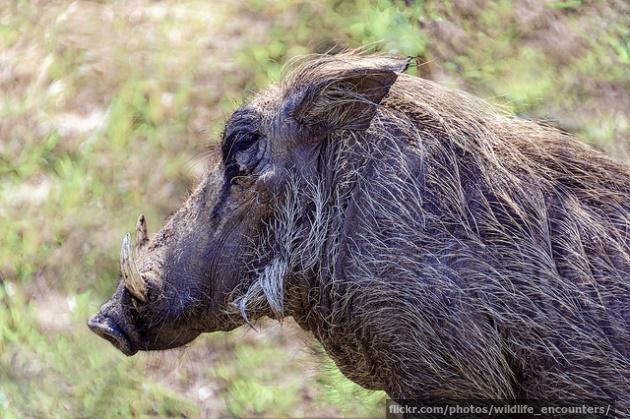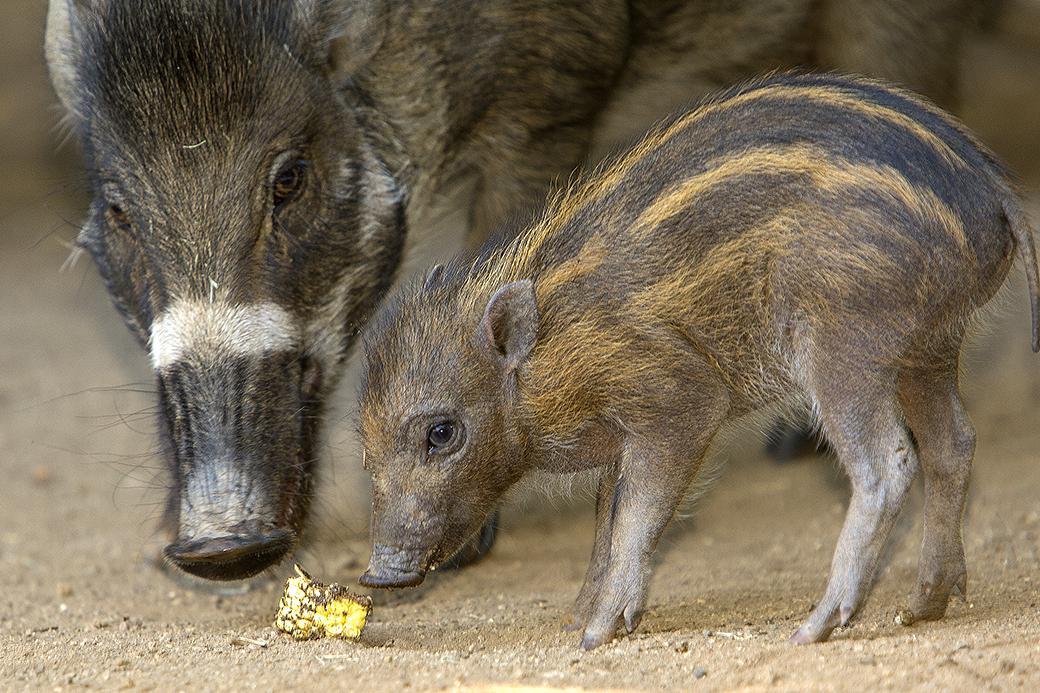The first image is the image on the left, the second image is the image on the right. Evaluate the accuracy of this statement regarding the images: "At least one pig has its snout on the ground.". Is it true? Answer yes or no. Yes. The first image is the image on the left, the second image is the image on the right. For the images shown, is this caption "There is one mammal facing to the side, and one mammal facing the camera." true? Answer yes or no. No. 